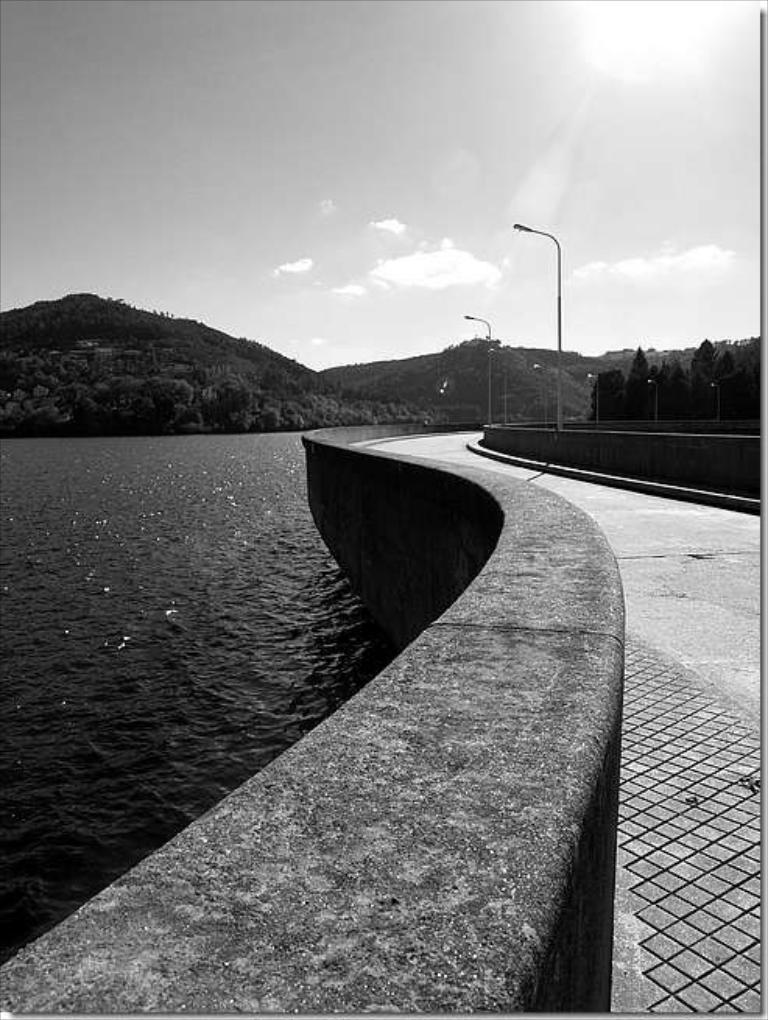What is the color scheme of the image? The image is black and white. What natural feature can be seen on the left side of the image? There is a river on the left side of the image. What man-made feature can be seen on the right side of the image? There is a road on the right side of the image. What structures are present along the road? There are light poles along the road. What type of landscape can be seen in the background of the image? There are mountains in the background of the image. What else is visible in the background of the image? The sky is visible in the background of the image. What type of sweater is being worn by the rose in the image? There is no sweater or rose present in the image; it features a black and white landscape with a river, road, light poles, mountains, and sky. 